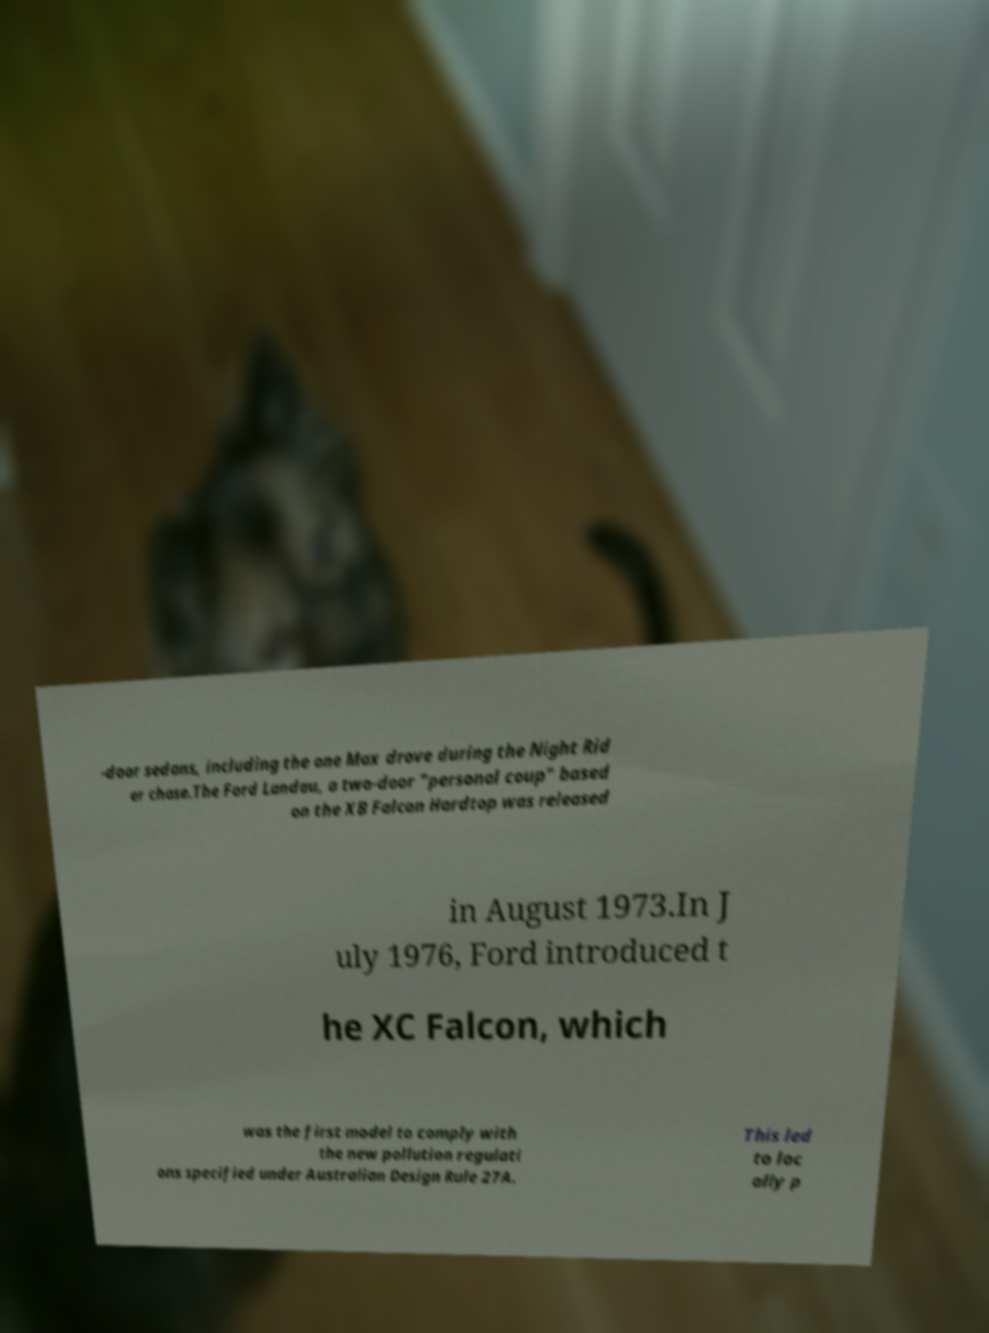Can you read and provide the text displayed in the image?This photo seems to have some interesting text. Can you extract and type it out for me? -door sedans, including the one Max drove during the Night Rid er chase.The Ford Landau, a two-door "personal coup" based on the XB Falcon Hardtop was released in August 1973.In J uly 1976, Ford introduced t he XC Falcon, which was the first model to comply with the new pollution regulati ons specified under Australian Design Rule 27A. This led to loc ally p 